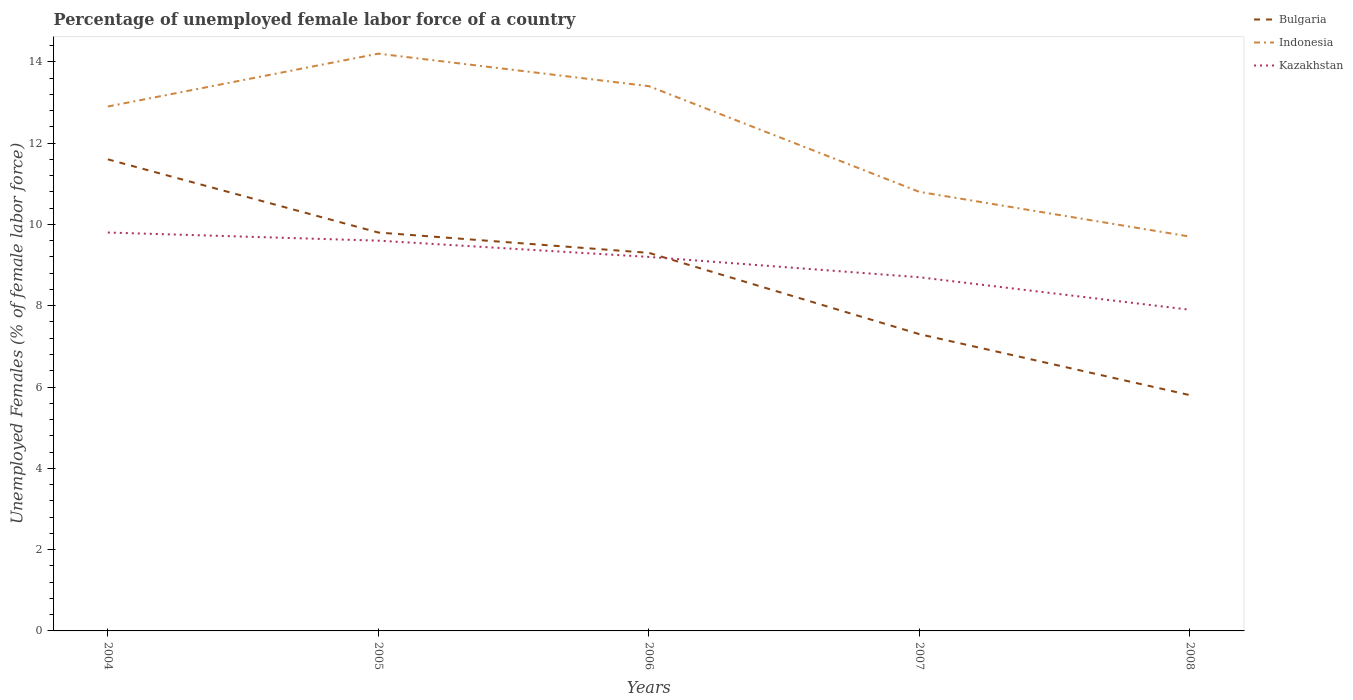Is the number of lines equal to the number of legend labels?
Make the answer very short. Yes. Across all years, what is the maximum percentage of unemployed female labor force in Indonesia?
Provide a short and direct response. 9.7. In which year was the percentage of unemployed female labor force in Indonesia maximum?
Your answer should be very brief. 2008. What is the total percentage of unemployed female labor force in Kazakhstan in the graph?
Give a very brief answer. 0.5. What is the difference between the highest and the second highest percentage of unemployed female labor force in Kazakhstan?
Make the answer very short. 1.9. How many lines are there?
Provide a short and direct response. 3. How many years are there in the graph?
Offer a terse response. 5. Does the graph contain any zero values?
Keep it short and to the point. No. Does the graph contain grids?
Provide a short and direct response. No. Where does the legend appear in the graph?
Make the answer very short. Top right. How many legend labels are there?
Give a very brief answer. 3. What is the title of the graph?
Give a very brief answer. Percentage of unemployed female labor force of a country. Does "Angola" appear as one of the legend labels in the graph?
Give a very brief answer. No. What is the label or title of the X-axis?
Offer a very short reply. Years. What is the label or title of the Y-axis?
Make the answer very short. Unemployed Females (% of female labor force). What is the Unemployed Females (% of female labor force) of Bulgaria in 2004?
Ensure brevity in your answer.  11.6. What is the Unemployed Females (% of female labor force) in Indonesia in 2004?
Provide a succinct answer. 12.9. What is the Unemployed Females (% of female labor force) of Kazakhstan in 2004?
Provide a short and direct response. 9.8. What is the Unemployed Females (% of female labor force) of Bulgaria in 2005?
Keep it short and to the point. 9.8. What is the Unemployed Females (% of female labor force) of Indonesia in 2005?
Ensure brevity in your answer.  14.2. What is the Unemployed Females (% of female labor force) in Kazakhstan in 2005?
Provide a short and direct response. 9.6. What is the Unemployed Females (% of female labor force) of Bulgaria in 2006?
Provide a succinct answer. 9.3. What is the Unemployed Females (% of female labor force) of Indonesia in 2006?
Offer a very short reply. 13.4. What is the Unemployed Females (% of female labor force) in Kazakhstan in 2006?
Offer a terse response. 9.2. What is the Unemployed Females (% of female labor force) of Bulgaria in 2007?
Offer a terse response. 7.3. What is the Unemployed Females (% of female labor force) in Indonesia in 2007?
Offer a terse response. 10.8. What is the Unemployed Females (% of female labor force) in Kazakhstan in 2007?
Give a very brief answer. 8.7. What is the Unemployed Females (% of female labor force) in Bulgaria in 2008?
Your response must be concise. 5.8. What is the Unemployed Females (% of female labor force) in Indonesia in 2008?
Ensure brevity in your answer.  9.7. What is the Unemployed Females (% of female labor force) of Kazakhstan in 2008?
Offer a very short reply. 7.9. Across all years, what is the maximum Unemployed Females (% of female labor force) in Bulgaria?
Your response must be concise. 11.6. Across all years, what is the maximum Unemployed Females (% of female labor force) in Indonesia?
Offer a terse response. 14.2. Across all years, what is the maximum Unemployed Females (% of female labor force) in Kazakhstan?
Give a very brief answer. 9.8. Across all years, what is the minimum Unemployed Females (% of female labor force) in Bulgaria?
Give a very brief answer. 5.8. Across all years, what is the minimum Unemployed Females (% of female labor force) of Indonesia?
Ensure brevity in your answer.  9.7. Across all years, what is the minimum Unemployed Females (% of female labor force) of Kazakhstan?
Make the answer very short. 7.9. What is the total Unemployed Females (% of female labor force) in Bulgaria in the graph?
Provide a succinct answer. 43.8. What is the total Unemployed Females (% of female labor force) in Kazakhstan in the graph?
Offer a terse response. 45.2. What is the difference between the Unemployed Females (% of female labor force) in Kazakhstan in 2004 and that in 2005?
Your response must be concise. 0.2. What is the difference between the Unemployed Females (% of female labor force) in Bulgaria in 2004 and that in 2006?
Your answer should be compact. 2.3. What is the difference between the Unemployed Females (% of female labor force) of Kazakhstan in 2004 and that in 2006?
Offer a terse response. 0.6. What is the difference between the Unemployed Females (% of female labor force) of Indonesia in 2004 and that in 2007?
Make the answer very short. 2.1. What is the difference between the Unemployed Females (% of female labor force) in Bulgaria in 2004 and that in 2008?
Provide a succinct answer. 5.8. What is the difference between the Unemployed Females (% of female labor force) in Indonesia in 2004 and that in 2008?
Your answer should be very brief. 3.2. What is the difference between the Unemployed Females (% of female labor force) in Indonesia in 2005 and that in 2006?
Your response must be concise. 0.8. What is the difference between the Unemployed Females (% of female labor force) of Kazakhstan in 2005 and that in 2006?
Keep it short and to the point. 0.4. What is the difference between the Unemployed Females (% of female labor force) of Bulgaria in 2005 and that in 2007?
Your answer should be compact. 2.5. What is the difference between the Unemployed Females (% of female labor force) of Indonesia in 2005 and that in 2008?
Provide a succinct answer. 4.5. What is the difference between the Unemployed Females (% of female labor force) in Kazakhstan in 2005 and that in 2008?
Your response must be concise. 1.7. What is the difference between the Unemployed Females (% of female labor force) of Bulgaria in 2006 and that in 2007?
Provide a short and direct response. 2. What is the difference between the Unemployed Females (% of female labor force) in Indonesia in 2006 and that in 2007?
Give a very brief answer. 2.6. What is the difference between the Unemployed Females (% of female labor force) of Indonesia in 2006 and that in 2008?
Keep it short and to the point. 3.7. What is the difference between the Unemployed Females (% of female labor force) in Kazakhstan in 2006 and that in 2008?
Keep it short and to the point. 1.3. What is the difference between the Unemployed Females (% of female labor force) of Bulgaria in 2007 and that in 2008?
Ensure brevity in your answer.  1.5. What is the difference between the Unemployed Females (% of female labor force) of Indonesia in 2007 and that in 2008?
Make the answer very short. 1.1. What is the difference between the Unemployed Females (% of female labor force) in Bulgaria in 2004 and the Unemployed Females (% of female labor force) in Indonesia in 2005?
Offer a terse response. -2.6. What is the difference between the Unemployed Females (% of female labor force) in Indonesia in 2004 and the Unemployed Females (% of female labor force) in Kazakhstan in 2005?
Provide a succinct answer. 3.3. What is the difference between the Unemployed Females (% of female labor force) in Bulgaria in 2004 and the Unemployed Females (% of female labor force) in Indonesia in 2006?
Offer a terse response. -1.8. What is the difference between the Unemployed Females (% of female labor force) of Bulgaria in 2004 and the Unemployed Females (% of female labor force) of Indonesia in 2007?
Make the answer very short. 0.8. What is the difference between the Unemployed Females (% of female labor force) in Bulgaria in 2004 and the Unemployed Females (% of female labor force) in Indonesia in 2008?
Ensure brevity in your answer.  1.9. What is the difference between the Unemployed Females (% of female labor force) of Bulgaria in 2004 and the Unemployed Females (% of female labor force) of Kazakhstan in 2008?
Your answer should be very brief. 3.7. What is the difference between the Unemployed Females (% of female labor force) of Indonesia in 2004 and the Unemployed Females (% of female labor force) of Kazakhstan in 2008?
Make the answer very short. 5. What is the difference between the Unemployed Females (% of female labor force) in Bulgaria in 2005 and the Unemployed Females (% of female labor force) in Indonesia in 2006?
Keep it short and to the point. -3.6. What is the difference between the Unemployed Females (% of female labor force) of Indonesia in 2005 and the Unemployed Females (% of female labor force) of Kazakhstan in 2006?
Offer a terse response. 5. What is the difference between the Unemployed Females (% of female labor force) in Bulgaria in 2005 and the Unemployed Females (% of female labor force) in Indonesia in 2007?
Your answer should be very brief. -1. What is the difference between the Unemployed Females (% of female labor force) of Bulgaria in 2005 and the Unemployed Females (% of female labor force) of Kazakhstan in 2007?
Give a very brief answer. 1.1. What is the difference between the Unemployed Females (% of female labor force) in Bulgaria in 2005 and the Unemployed Females (% of female labor force) in Indonesia in 2008?
Make the answer very short. 0.1. What is the difference between the Unemployed Females (% of female labor force) of Indonesia in 2005 and the Unemployed Females (% of female labor force) of Kazakhstan in 2008?
Your answer should be very brief. 6.3. What is the difference between the Unemployed Females (% of female labor force) in Bulgaria in 2006 and the Unemployed Females (% of female labor force) in Indonesia in 2007?
Your response must be concise. -1.5. What is the difference between the Unemployed Females (% of female labor force) in Indonesia in 2006 and the Unemployed Females (% of female labor force) in Kazakhstan in 2007?
Your answer should be compact. 4.7. What is the difference between the Unemployed Females (% of female labor force) of Bulgaria in 2006 and the Unemployed Females (% of female labor force) of Kazakhstan in 2008?
Your response must be concise. 1.4. What is the difference between the Unemployed Females (% of female labor force) in Bulgaria in 2007 and the Unemployed Females (% of female labor force) in Kazakhstan in 2008?
Your response must be concise. -0.6. What is the average Unemployed Females (% of female labor force) of Bulgaria per year?
Provide a succinct answer. 8.76. What is the average Unemployed Females (% of female labor force) of Indonesia per year?
Your response must be concise. 12.2. What is the average Unemployed Females (% of female labor force) in Kazakhstan per year?
Give a very brief answer. 9.04. In the year 2004, what is the difference between the Unemployed Females (% of female labor force) in Bulgaria and Unemployed Females (% of female labor force) in Kazakhstan?
Your response must be concise. 1.8. In the year 2004, what is the difference between the Unemployed Females (% of female labor force) of Indonesia and Unemployed Females (% of female labor force) of Kazakhstan?
Make the answer very short. 3.1. In the year 2005, what is the difference between the Unemployed Females (% of female labor force) of Bulgaria and Unemployed Females (% of female labor force) of Kazakhstan?
Your answer should be very brief. 0.2. In the year 2005, what is the difference between the Unemployed Females (% of female labor force) of Indonesia and Unemployed Females (% of female labor force) of Kazakhstan?
Provide a short and direct response. 4.6. In the year 2006, what is the difference between the Unemployed Females (% of female labor force) in Indonesia and Unemployed Females (% of female labor force) in Kazakhstan?
Offer a very short reply. 4.2. In the year 2007, what is the difference between the Unemployed Females (% of female labor force) in Bulgaria and Unemployed Females (% of female labor force) in Indonesia?
Offer a very short reply. -3.5. In the year 2007, what is the difference between the Unemployed Females (% of female labor force) of Bulgaria and Unemployed Females (% of female labor force) of Kazakhstan?
Make the answer very short. -1.4. In the year 2008, what is the difference between the Unemployed Females (% of female labor force) of Bulgaria and Unemployed Females (% of female labor force) of Kazakhstan?
Offer a terse response. -2.1. In the year 2008, what is the difference between the Unemployed Females (% of female labor force) in Indonesia and Unemployed Females (% of female labor force) in Kazakhstan?
Your answer should be compact. 1.8. What is the ratio of the Unemployed Females (% of female labor force) in Bulgaria in 2004 to that in 2005?
Ensure brevity in your answer.  1.18. What is the ratio of the Unemployed Females (% of female labor force) of Indonesia in 2004 to that in 2005?
Your answer should be very brief. 0.91. What is the ratio of the Unemployed Females (% of female labor force) of Kazakhstan in 2004 to that in 2005?
Offer a terse response. 1.02. What is the ratio of the Unemployed Females (% of female labor force) of Bulgaria in 2004 to that in 2006?
Make the answer very short. 1.25. What is the ratio of the Unemployed Females (% of female labor force) in Indonesia in 2004 to that in 2006?
Provide a succinct answer. 0.96. What is the ratio of the Unemployed Females (% of female labor force) of Kazakhstan in 2004 to that in 2006?
Your response must be concise. 1.07. What is the ratio of the Unemployed Females (% of female labor force) in Bulgaria in 2004 to that in 2007?
Your answer should be compact. 1.59. What is the ratio of the Unemployed Females (% of female labor force) of Indonesia in 2004 to that in 2007?
Your response must be concise. 1.19. What is the ratio of the Unemployed Females (% of female labor force) of Kazakhstan in 2004 to that in 2007?
Provide a succinct answer. 1.13. What is the ratio of the Unemployed Females (% of female labor force) in Bulgaria in 2004 to that in 2008?
Give a very brief answer. 2. What is the ratio of the Unemployed Females (% of female labor force) of Indonesia in 2004 to that in 2008?
Offer a terse response. 1.33. What is the ratio of the Unemployed Females (% of female labor force) in Kazakhstan in 2004 to that in 2008?
Give a very brief answer. 1.24. What is the ratio of the Unemployed Females (% of female labor force) in Bulgaria in 2005 to that in 2006?
Make the answer very short. 1.05. What is the ratio of the Unemployed Females (% of female labor force) in Indonesia in 2005 to that in 2006?
Provide a succinct answer. 1.06. What is the ratio of the Unemployed Females (% of female labor force) of Kazakhstan in 2005 to that in 2006?
Your answer should be compact. 1.04. What is the ratio of the Unemployed Females (% of female labor force) of Bulgaria in 2005 to that in 2007?
Your response must be concise. 1.34. What is the ratio of the Unemployed Females (% of female labor force) in Indonesia in 2005 to that in 2007?
Your answer should be very brief. 1.31. What is the ratio of the Unemployed Females (% of female labor force) in Kazakhstan in 2005 to that in 2007?
Offer a terse response. 1.1. What is the ratio of the Unemployed Females (% of female labor force) of Bulgaria in 2005 to that in 2008?
Provide a succinct answer. 1.69. What is the ratio of the Unemployed Females (% of female labor force) in Indonesia in 2005 to that in 2008?
Your answer should be compact. 1.46. What is the ratio of the Unemployed Females (% of female labor force) in Kazakhstan in 2005 to that in 2008?
Offer a terse response. 1.22. What is the ratio of the Unemployed Females (% of female labor force) of Bulgaria in 2006 to that in 2007?
Provide a succinct answer. 1.27. What is the ratio of the Unemployed Females (% of female labor force) of Indonesia in 2006 to that in 2007?
Keep it short and to the point. 1.24. What is the ratio of the Unemployed Females (% of female labor force) of Kazakhstan in 2006 to that in 2007?
Offer a very short reply. 1.06. What is the ratio of the Unemployed Females (% of female labor force) of Bulgaria in 2006 to that in 2008?
Ensure brevity in your answer.  1.6. What is the ratio of the Unemployed Females (% of female labor force) in Indonesia in 2006 to that in 2008?
Your response must be concise. 1.38. What is the ratio of the Unemployed Females (% of female labor force) of Kazakhstan in 2006 to that in 2008?
Keep it short and to the point. 1.16. What is the ratio of the Unemployed Females (% of female labor force) of Bulgaria in 2007 to that in 2008?
Your response must be concise. 1.26. What is the ratio of the Unemployed Females (% of female labor force) of Indonesia in 2007 to that in 2008?
Provide a succinct answer. 1.11. What is the ratio of the Unemployed Females (% of female labor force) of Kazakhstan in 2007 to that in 2008?
Offer a very short reply. 1.1. What is the difference between the highest and the second highest Unemployed Females (% of female labor force) in Indonesia?
Make the answer very short. 0.8. What is the difference between the highest and the second highest Unemployed Females (% of female labor force) in Kazakhstan?
Offer a very short reply. 0.2. What is the difference between the highest and the lowest Unemployed Females (% of female labor force) of Bulgaria?
Keep it short and to the point. 5.8. What is the difference between the highest and the lowest Unemployed Females (% of female labor force) in Indonesia?
Provide a short and direct response. 4.5. 